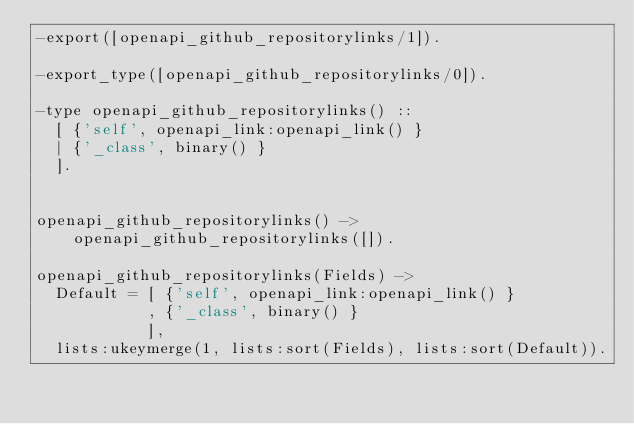<code> <loc_0><loc_0><loc_500><loc_500><_Erlang_>-export([openapi_github_repositorylinks/1]).

-export_type([openapi_github_repositorylinks/0]).

-type openapi_github_repositorylinks() ::
  [ {'self', openapi_link:openapi_link() }
  | {'_class', binary() }
  ].


openapi_github_repositorylinks() ->
    openapi_github_repositorylinks([]).

openapi_github_repositorylinks(Fields) ->
  Default = [ {'self', openapi_link:openapi_link() }
            , {'_class', binary() }
            ],
  lists:ukeymerge(1, lists:sort(Fields), lists:sort(Default)).

</code> 